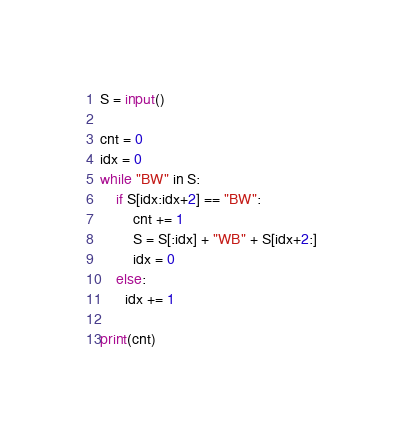<code> <loc_0><loc_0><loc_500><loc_500><_Python_>S = input()

cnt = 0
idx = 0
while "BW" in S:
    if S[idx:idx+2] == "BW":
        cnt += 1
        S = S[:idx] + "WB" + S[idx+2:]
        idx = 0
    else:
      idx += 1
      
print(cnt)
</code> 